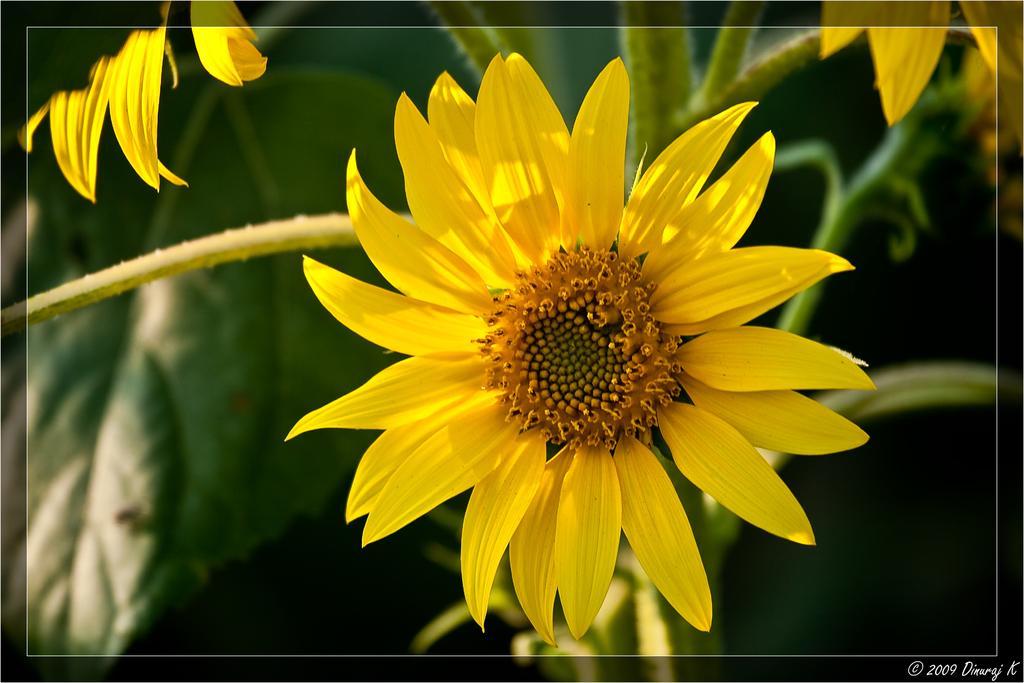Describe this image in one or two sentences. This is a photo. In this picture we can see the flowers, leaves and stems. In the background, the image is blurred. In the bottom right corner we can see the text. 